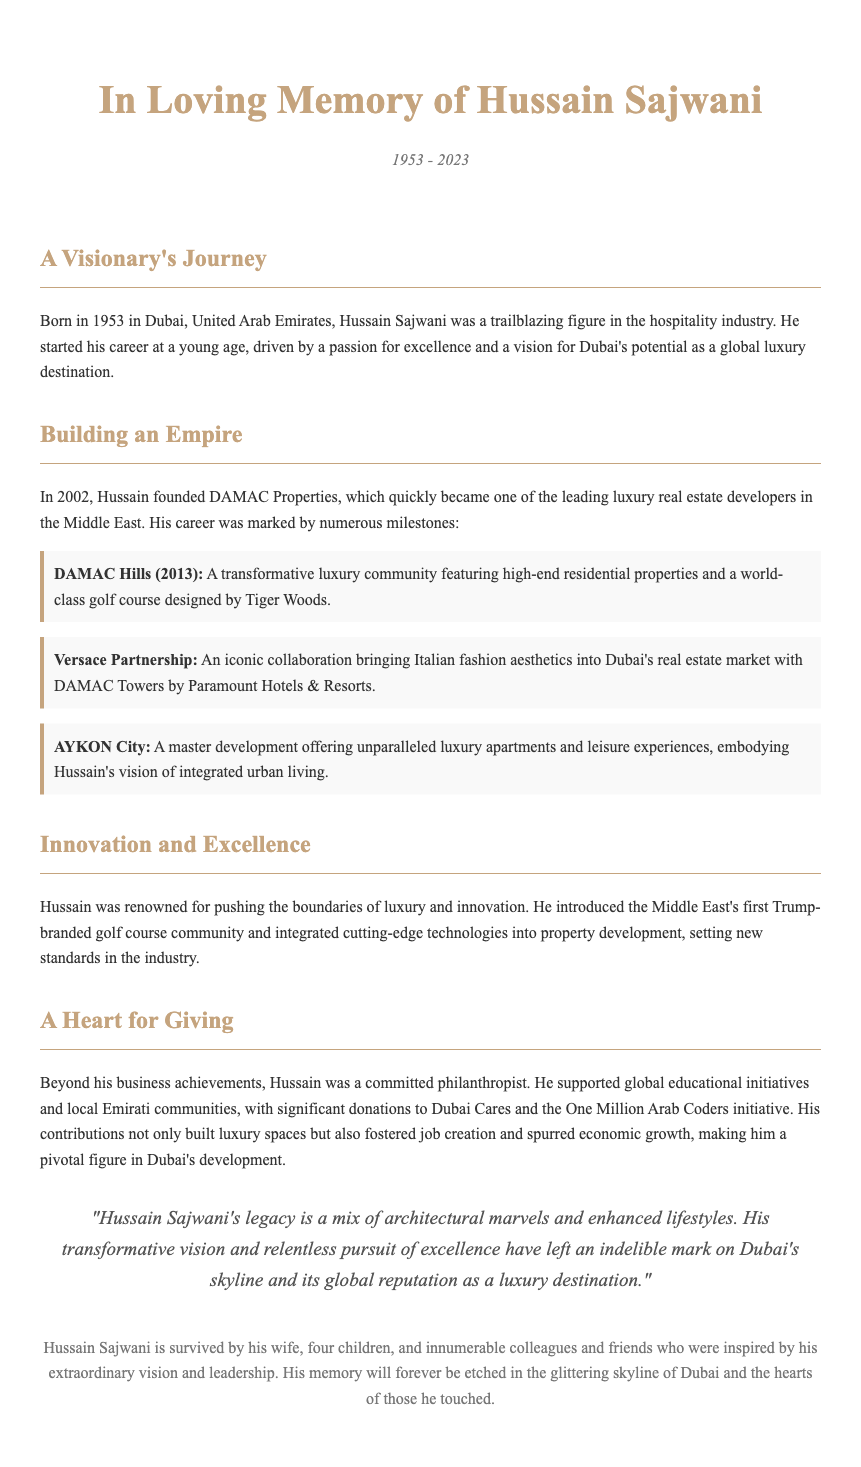What year was Hussain Sajwani born? The document states that Hussain Sajwani was born in 1953.
Answer: 1953 What significant company did Hussain Sajwani found in 2002? The document mentions that Hussain founded DAMAC Properties in 2002.
Answer: DAMAC Properties What is the name of the golf course community designed by Tiger Woods? The document highlights DAMAC Hills as a transformative luxury community featuring a golf course designed by Tiger Woods.
Answer: DAMAC Hills What philanthropic initiatives did Hussain support? The document notes significant donations to Dubai Cares and the One Million Arab Coders initiative as part of Hussain's philanthropic efforts.
Answer: Dubai Cares and the One Million Arab Coders How many children did Hussain Sajwani leave behind? The document states he is survived by four children.
Answer: Four 